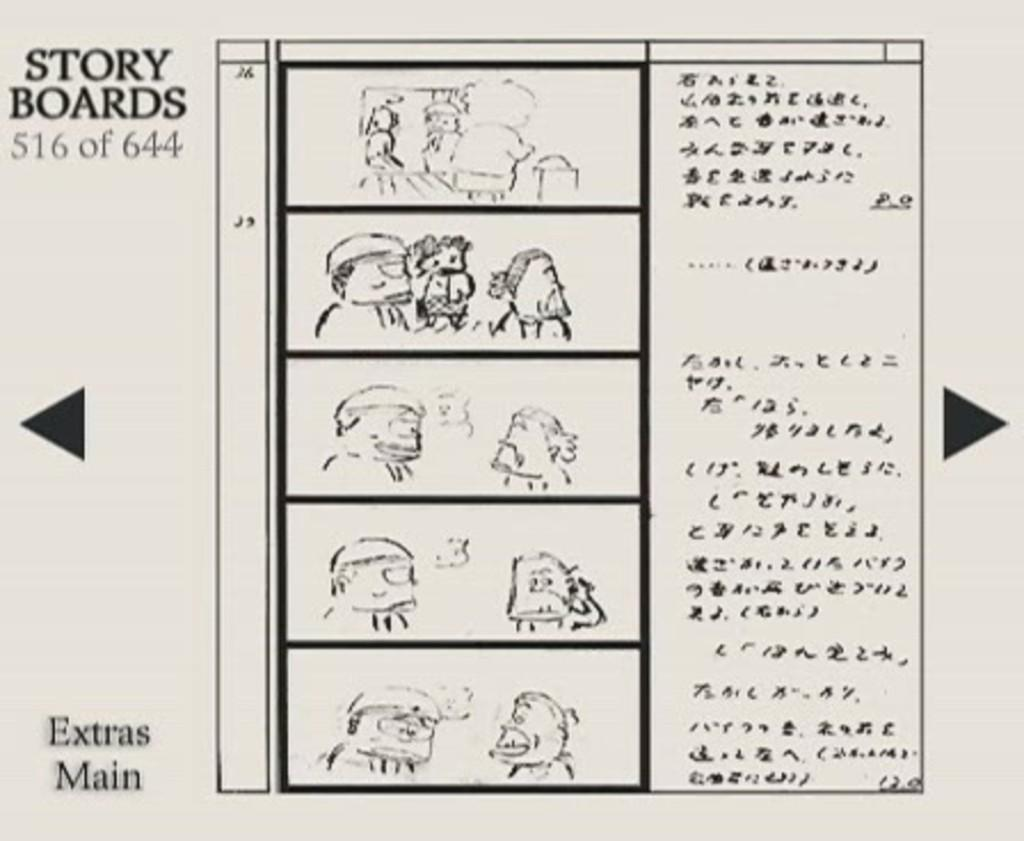What is present on the paper in the image? The paper contains printed text and images. Can you describe the images on the paper? The images on the paper are in black color. How is the kite being used in the image? There is no kite present in the image. What type of cast is being performed in the image? There is no cast being performed in the image. Can you describe the chess pieces in the image? There are no chess pieces present in the image. 